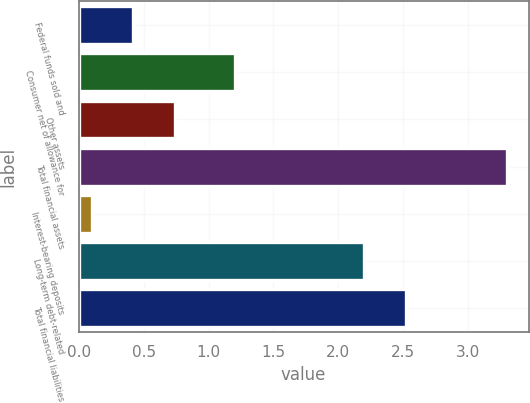Convert chart. <chart><loc_0><loc_0><loc_500><loc_500><bar_chart><fcel>Federal funds sold and<fcel>Consumer net of allowance for<fcel>Other assets<fcel>Total financial assets<fcel>Interest-bearing deposits<fcel>Long-term debt-related<fcel>Total financial liabilities<nl><fcel>0.42<fcel>1.2<fcel>0.74<fcel>3.3<fcel>0.1<fcel>2.2<fcel>2.52<nl></chart> 